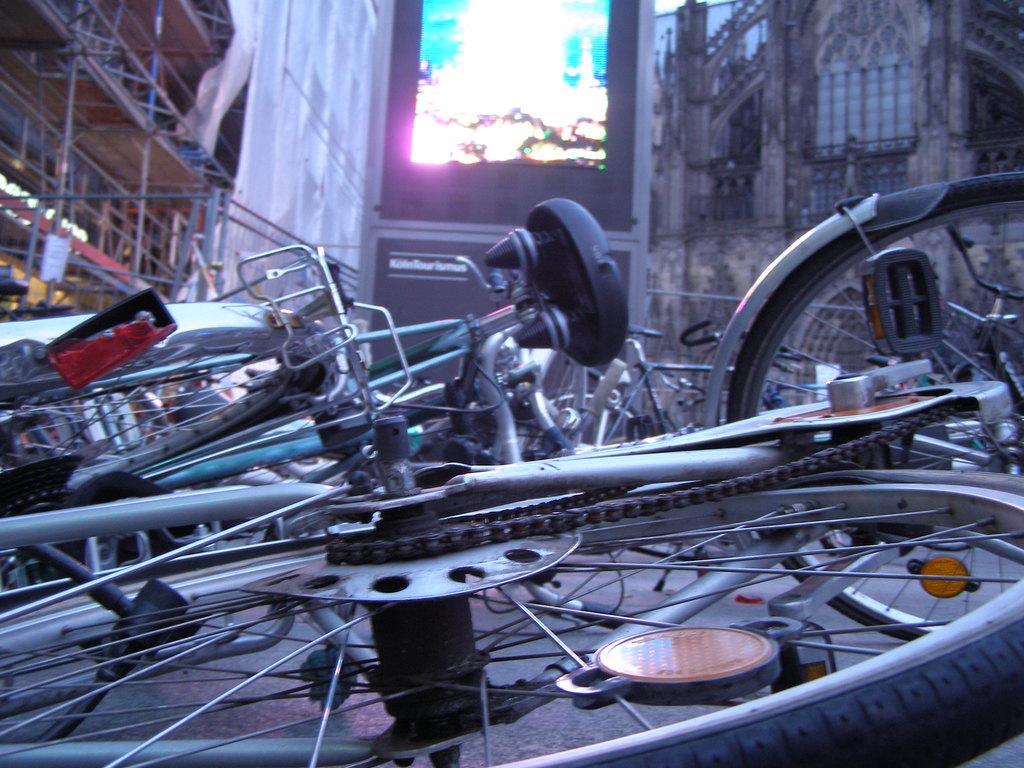Can you describe this image briefly? In this picture I can see few bicycles and couple of them are on the ground and i can see buildings. 